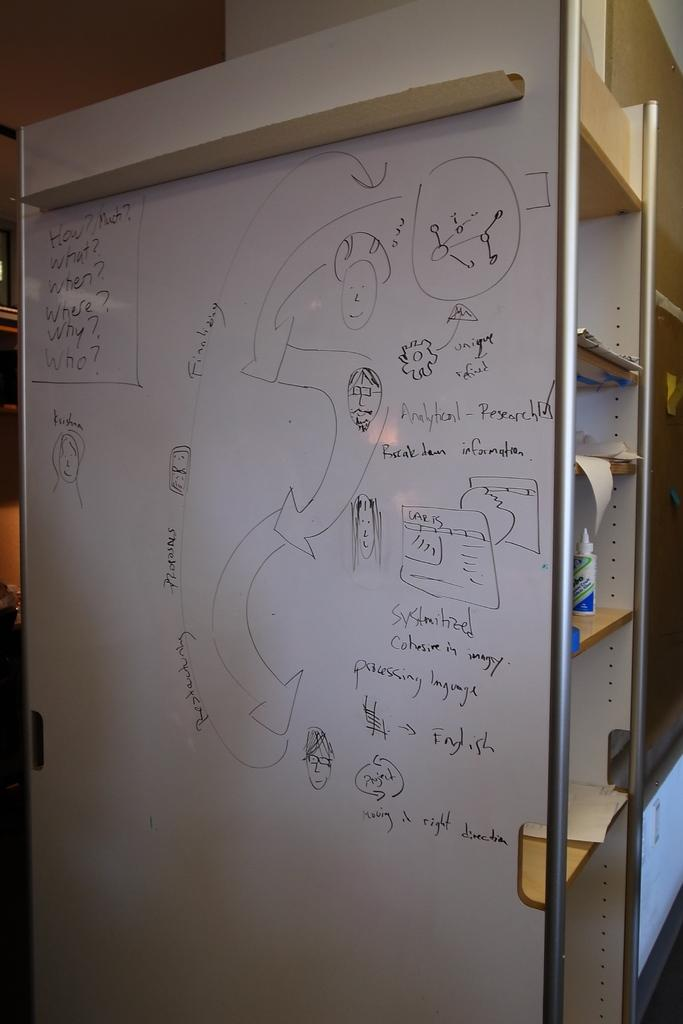Provide a one-sentence caption for the provided image. A white board that asks How? What? When? Where? Why? and Who on the side. 